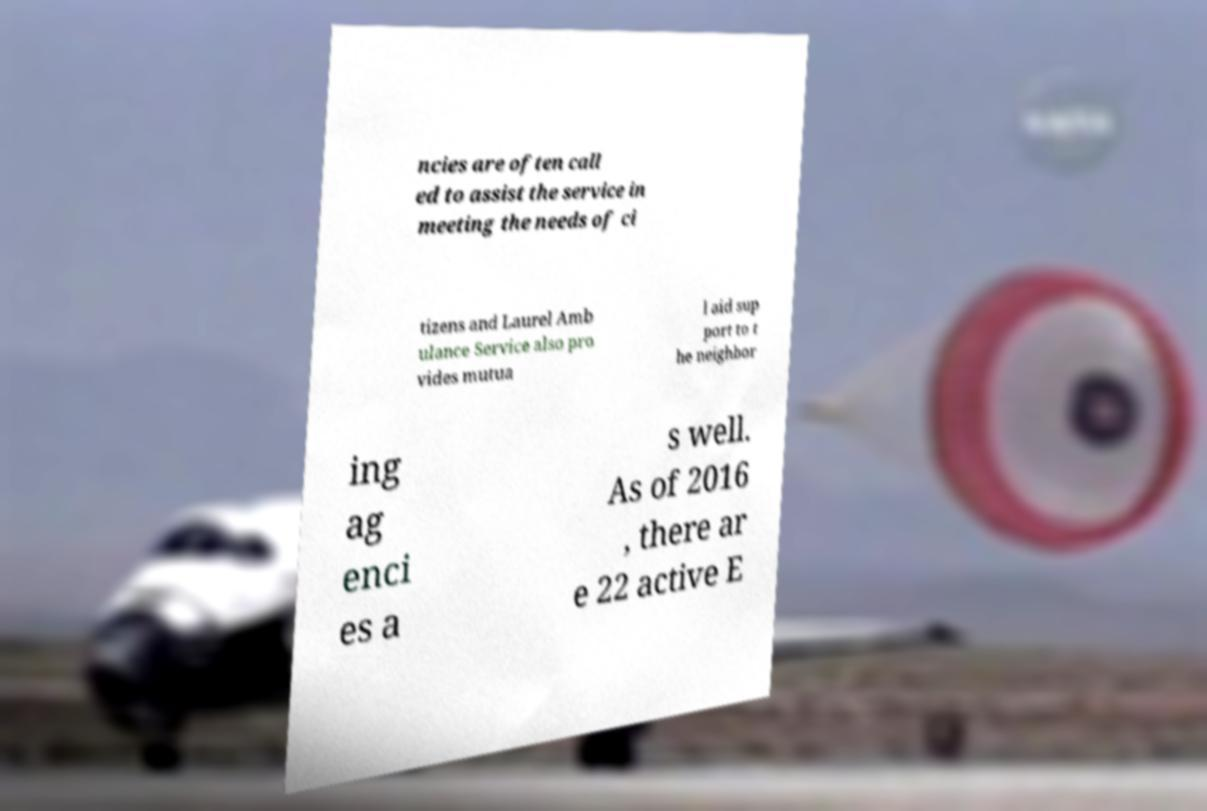There's text embedded in this image that I need extracted. Can you transcribe it verbatim? ncies are often call ed to assist the service in meeting the needs of ci tizens and Laurel Amb ulance Service also pro vides mutua l aid sup port to t he neighbor ing ag enci es a s well. As of 2016 , there ar e 22 active E 